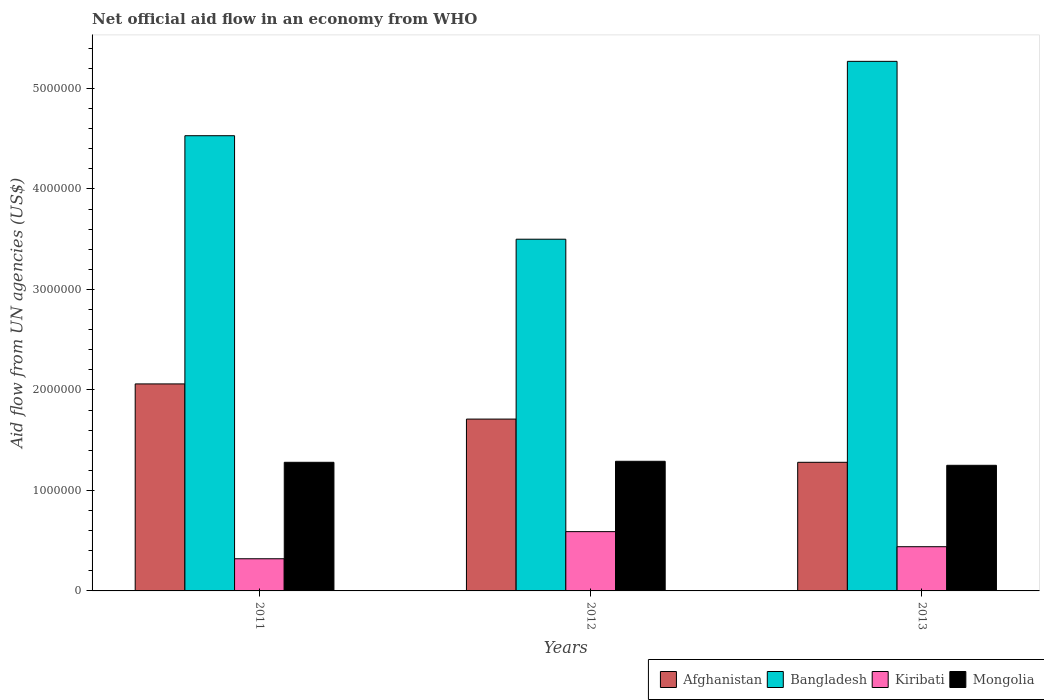How many different coloured bars are there?
Offer a terse response. 4. How many bars are there on the 1st tick from the left?
Offer a terse response. 4. How many bars are there on the 3rd tick from the right?
Keep it short and to the point. 4. What is the label of the 1st group of bars from the left?
Your response must be concise. 2011. What is the net official aid flow in Bangladesh in 2013?
Provide a short and direct response. 5.27e+06. Across all years, what is the maximum net official aid flow in Afghanistan?
Make the answer very short. 2.06e+06. Across all years, what is the minimum net official aid flow in Afghanistan?
Provide a succinct answer. 1.28e+06. In which year was the net official aid flow in Bangladesh maximum?
Provide a short and direct response. 2013. In which year was the net official aid flow in Kiribati minimum?
Provide a short and direct response. 2011. What is the total net official aid flow in Kiribati in the graph?
Your answer should be compact. 1.35e+06. What is the difference between the net official aid flow in Mongolia in 2011 and the net official aid flow in Bangladesh in 2012?
Your answer should be compact. -2.22e+06. What is the average net official aid flow in Bangladesh per year?
Your answer should be very brief. 4.43e+06. In the year 2011, what is the difference between the net official aid flow in Kiribati and net official aid flow in Bangladesh?
Your answer should be compact. -4.21e+06. What is the ratio of the net official aid flow in Afghanistan in 2012 to that in 2013?
Your response must be concise. 1.34. Is the net official aid flow in Bangladesh in 2011 less than that in 2013?
Keep it short and to the point. Yes. What is the difference between the highest and the second highest net official aid flow in Mongolia?
Offer a very short reply. 10000. What is the difference between the highest and the lowest net official aid flow in Kiribati?
Ensure brevity in your answer.  2.70e+05. In how many years, is the net official aid flow in Kiribati greater than the average net official aid flow in Kiribati taken over all years?
Make the answer very short. 1. Is the sum of the net official aid flow in Mongolia in 2011 and 2012 greater than the maximum net official aid flow in Afghanistan across all years?
Keep it short and to the point. Yes. What does the 3rd bar from the left in 2013 represents?
Your answer should be compact. Kiribati. What does the 1st bar from the right in 2013 represents?
Make the answer very short. Mongolia. Is it the case that in every year, the sum of the net official aid flow in Kiribati and net official aid flow in Afghanistan is greater than the net official aid flow in Mongolia?
Provide a succinct answer. Yes. How many years are there in the graph?
Give a very brief answer. 3. What is the difference between two consecutive major ticks on the Y-axis?
Offer a very short reply. 1.00e+06. Does the graph contain any zero values?
Offer a terse response. No. Does the graph contain grids?
Ensure brevity in your answer.  No. Where does the legend appear in the graph?
Make the answer very short. Bottom right. How many legend labels are there?
Make the answer very short. 4. How are the legend labels stacked?
Keep it short and to the point. Horizontal. What is the title of the graph?
Your answer should be compact. Net official aid flow in an economy from WHO. What is the label or title of the X-axis?
Keep it short and to the point. Years. What is the label or title of the Y-axis?
Offer a terse response. Aid flow from UN agencies (US$). What is the Aid flow from UN agencies (US$) in Afghanistan in 2011?
Your response must be concise. 2.06e+06. What is the Aid flow from UN agencies (US$) of Bangladesh in 2011?
Provide a succinct answer. 4.53e+06. What is the Aid flow from UN agencies (US$) in Mongolia in 2011?
Make the answer very short. 1.28e+06. What is the Aid flow from UN agencies (US$) of Afghanistan in 2012?
Offer a terse response. 1.71e+06. What is the Aid flow from UN agencies (US$) in Bangladesh in 2012?
Ensure brevity in your answer.  3.50e+06. What is the Aid flow from UN agencies (US$) in Kiribati in 2012?
Offer a terse response. 5.90e+05. What is the Aid flow from UN agencies (US$) of Mongolia in 2012?
Your answer should be very brief. 1.29e+06. What is the Aid flow from UN agencies (US$) in Afghanistan in 2013?
Your answer should be compact. 1.28e+06. What is the Aid flow from UN agencies (US$) of Bangladesh in 2013?
Your answer should be compact. 5.27e+06. What is the Aid flow from UN agencies (US$) in Mongolia in 2013?
Provide a succinct answer. 1.25e+06. Across all years, what is the maximum Aid flow from UN agencies (US$) in Afghanistan?
Offer a terse response. 2.06e+06. Across all years, what is the maximum Aid flow from UN agencies (US$) of Bangladesh?
Your answer should be compact. 5.27e+06. Across all years, what is the maximum Aid flow from UN agencies (US$) in Kiribati?
Your answer should be very brief. 5.90e+05. Across all years, what is the maximum Aid flow from UN agencies (US$) of Mongolia?
Keep it short and to the point. 1.29e+06. Across all years, what is the minimum Aid flow from UN agencies (US$) in Afghanistan?
Offer a terse response. 1.28e+06. Across all years, what is the minimum Aid flow from UN agencies (US$) of Bangladesh?
Give a very brief answer. 3.50e+06. Across all years, what is the minimum Aid flow from UN agencies (US$) of Kiribati?
Your answer should be very brief. 3.20e+05. Across all years, what is the minimum Aid flow from UN agencies (US$) in Mongolia?
Give a very brief answer. 1.25e+06. What is the total Aid flow from UN agencies (US$) of Afghanistan in the graph?
Your answer should be very brief. 5.05e+06. What is the total Aid flow from UN agencies (US$) in Bangladesh in the graph?
Your answer should be compact. 1.33e+07. What is the total Aid flow from UN agencies (US$) in Kiribati in the graph?
Provide a short and direct response. 1.35e+06. What is the total Aid flow from UN agencies (US$) in Mongolia in the graph?
Ensure brevity in your answer.  3.82e+06. What is the difference between the Aid flow from UN agencies (US$) in Afghanistan in 2011 and that in 2012?
Give a very brief answer. 3.50e+05. What is the difference between the Aid flow from UN agencies (US$) in Bangladesh in 2011 and that in 2012?
Your response must be concise. 1.03e+06. What is the difference between the Aid flow from UN agencies (US$) in Afghanistan in 2011 and that in 2013?
Offer a very short reply. 7.80e+05. What is the difference between the Aid flow from UN agencies (US$) in Bangladesh in 2011 and that in 2013?
Your answer should be very brief. -7.40e+05. What is the difference between the Aid flow from UN agencies (US$) in Bangladesh in 2012 and that in 2013?
Keep it short and to the point. -1.77e+06. What is the difference between the Aid flow from UN agencies (US$) in Afghanistan in 2011 and the Aid flow from UN agencies (US$) in Bangladesh in 2012?
Your response must be concise. -1.44e+06. What is the difference between the Aid flow from UN agencies (US$) of Afghanistan in 2011 and the Aid flow from UN agencies (US$) of Kiribati in 2012?
Your answer should be compact. 1.47e+06. What is the difference between the Aid flow from UN agencies (US$) of Afghanistan in 2011 and the Aid flow from UN agencies (US$) of Mongolia in 2012?
Make the answer very short. 7.70e+05. What is the difference between the Aid flow from UN agencies (US$) of Bangladesh in 2011 and the Aid flow from UN agencies (US$) of Kiribati in 2012?
Offer a terse response. 3.94e+06. What is the difference between the Aid flow from UN agencies (US$) in Bangladesh in 2011 and the Aid flow from UN agencies (US$) in Mongolia in 2012?
Ensure brevity in your answer.  3.24e+06. What is the difference between the Aid flow from UN agencies (US$) in Kiribati in 2011 and the Aid flow from UN agencies (US$) in Mongolia in 2012?
Offer a terse response. -9.70e+05. What is the difference between the Aid flow from UN agencies (US$) of Afghanistan in 2011 and the Aid flow from UN agencies (US$) of Bangladesh in 2013?
Keep it short and to the point. -3.21e+06. What is the difference between the Aid flow from UN agencies (US$) in Afghanistan in 2011 and the Aid flow from UN agencies (US$) in Kiribati in 2013?
Your answer should be very brief. 1.62e+06. What is the difference between the Aid flow from UN agencies (US$) in Afghanistan in 2011 and the Aid flow from UN agencies (US$) in Mongolia in 2013?
Your response must be concise. 8.10e+05. What is the difference between the Aid flow from UN agencies (US$) of Bangladesh in 2011 and the Aid flow from UN agencies (US$) of Kiribati in 2013?
Keep it short and to the point. 4.09e+06. What is the difference between the Aid flow from UN agencies (US$) of Bangladesh in 2011 and the Aid flow from UN agencies (US$) of Mongolia in 2013?
Offer a very short reply. 3.28e+06. What is the difference between the Aid flow from UN agencies (US$) of Kiribati in 2011 and the Aid flow from UN agencies (US$) of Mongolia in 2013?
Offer a terse response. -9.30e+05. What is the difference between the Aid flow from UN agencies (US$) of Afghanistan in 2012 and the Aid flow from UN agencies (US$) of Bangladesh in 2013?
Ensure brevity in your answer.  -3.56e+06. What is the difference between the Aid flow from UN agencies (US$) in Afghanistan in 2012 and the Aid flow from UN agencies (US$) in Kiribati in 2013?
Provide a succinct answer. 1.27e+06. What is the difference between the Aid flow from UN agencies (US$) of Bangladesh in 2012 and the Aid flow from UN agencies (US$) of Kiribati in 2013?
Your answer should be compact. 3.06e+06. What is the difference between the Aid flow from UN agencies (US$) in Bangladesh in 2012 and the Aid flow from UN agencies (US$) in Mongolia in 2013?
Ensure brevity in your answer.  2.25e+06. What is the difference between the Aid flow from UN agencies (US$) in Kiribati in 2012 and the Aid flow from UN agencies (US$) in Mongolia in 2013?
Your answer should be compact. -6.60e+05. What is the average Aid flow from UN agencies (US$) in Afghanistan per year?
Keep it short and to the point. 1.68e+06. What is the average Aid flow from UN agencies (US$) of Bangladesh per year?
Make the answer very short. 4.43e+06. What is the average Aid flow from UN agencies (US$) of Mongolia per year?
Keep it short and to the point. 1.27e+06. In the year 2011, what is the difference between the Aid flow from UN agencies (US$) of Afghanistan and Aid flow from UN agencies (US$) of Bangladesh?
Ensure brevity in your answer.  -2.47e+06. In the year 2011, what is the difference between the Aid flow from UN agencies (US$) in Afghanistan and Aid flow from UN agencies (US$) in Kiribati?
Give a very brief answer. 1.74e+06. In the year 2011, what is the difference between the Aid flow from UN agencies (US$) of Afghanistan and Aid flow from UN agencies (US$) of Mongolia?
Your answer should be compact. 7.80e+05. In the year 2011, what is the difference between the Aid flow from UN agencies (US$) of Bangladesh and Aid flow from UN agencies (US$) of Kiribati?
Make the answer very short. 4.21e+06. In the year 2011, what is the difference between the Aid flow from UN agencies (US$) in Bangladesh and Aid flow from UN agencies (US$) in Mongolia?
Your response must be concise. 3.25e+06. In the year 2011, what is the difference between the Aid flow from UN agencies (US$) of Kiribati and Aid flow from UN agencies (US$) of Mongolia?
Ensure brevity in your answer.  -9.60e+05. In the year 2012, what is the difference between the Aid flow from UN agencies (US$) of Afghanistan and Aid flow from UN agencies (US$) of Bangladesh?
Provide a short and direct response. -1.79e+06. In the year 2012, what is the difference between the Aid flow from UN agencies (US$) in Afghanistan and Aid flow from UN agencies (US$) in Kiribati?
Offer a terse response. 1.12e+06. In the year 2012, what is the difference between the Aid flow from UN agencies (US$) of Afghanistan and Aid flow from UN agencies (US$) of Mongolia?
Ensure brevity in your answer.  4.20e+05. In the year 2012, what is the difference between the Aid flow from UN agencies (US$) in Bangladesh and Aid flow from UN agencies (US$) in Kiribati?
Your answer should be very brief. 2.91e+06. In the year 2012, what is the difference between the Aid flow from UN agencies (US$) in Bangladesh and Aid flow from UN agencies (US$) in Mongolia?
Provide a short and direct response. 2.21e+06. In the year 2012, what is the difference between the Aid flow from UN agencies (US$) of Kiribati and Aid flow from UN agencies (US$) of Mongolia?
Your response must be concise. -7.00e+05. In the year 2013, what is the difference between the Aid flow from UN agencies (US$) in Afghanistan and Aid flow from UN agencies (US$) in Bangladesh?
Your answer should be compact. -3.99e+06. In the year 2013, what is the difference between the Aid flow from UN agencies (US$) of Afghanistan and Aid flow from UN agencies (US$) of Kiribati?
Provide a short and direct response. 8.40e+05. In the year 2013, what is the difference between the Aid flow from UN agencies (US$) in Bangladesh and Aid flow from UN agencies (US$) in Kiribati?
Give a very brief answer. 4.83e+06. In the year 2013, what is the difference between the Aid flow from UN agencies (US$) of Bangladesh and Aid flow from UN agencies (US$) of Mongolia?
Keep it short and to the point. 4.02e+06. In the year 2013, what is the difference between the Aid flow from UN agencies (US$) of Kiribati and Aid flow from UN agencies (US$) of Mongolia?
Give a very brief answer. -8.10e+05. What is the ratio of the Aid flow from UN agencies (US$) in Afghanistan in 2011 to that in 2012?
Keep it short and to the point. 1.2. What is the ratio of the Aid flow from UN agencies (US$) of Bangladesh in 2011 to that in 2012?
Make the answer very short. 1.29. What is the ratio of the Aid flow from UN agencies (US$) in Kiribati in 2011 to that in 2012?
Give a very brief answer. 0.54. What is the ratio of the Aid flow from UN agencies (US$) of Afghanistan in 2011 to that in 2013?
Your answer should be compact. 1.61. What is the ratio of the Aid flow from UN agencies (US$) in Bangladesh in 2011 to that in 2013?
Provide a short and direct response. 0.86. What is the ratio of the Aid flow from UN agencies (US$) in Kiribati in 2011 to that in 2013?
Your answer should be very brief. 0.73. What is the ratio of the Aid flow from UN agencies (US$) of Mongolia in 2011 to that in 2013?
Provide a succinct answer. 1.02. What is the ratio of the Aid flow from UN agencies (US$) in Afghanistan in 2012 to that in 2013?
Give a very brief answer. 1.34. What is the ratio of the Aid flow from UN agencies (US$) in Bangladesh in 2012 to that in 2013?
Provide a succinct answer. 0.66. What is the ratio of the Aid flow from UN agencies (US$) of Kiribati in 2012 to that in 2013?
Provide a succinct answer. 1.34. What is the ratio of the Aid flow from UN agencies (US$) of Mongolia in 2012 to that in 2013?
Give a very brief answer. 1.03. What is the difference between the highest and the second highest Aid flow from UN agencies (US$) in Bangladesh?
Offer a terse response. 7.40e+05. What is the difference between the highest and the second highest Aid flow from UN agencies (US$) in Kiribati?
Your answer should be compact. 1.50e+05. What is the difference between the highest and the lowest Aid flow from UN agencies (US$) of Afghanistan?
Your response must be concise. 7.80e+05. What is the difference between the highest and the lowest Aid flow from UN agencies (US$) in Bangladesh?
Keep it short and to the point. 1.77e+06. What is the difference between the highest and the lowest Aid flow from UN agencies (US$) of Mongolia?
Provide a short and direct response. 4.00e+04. 